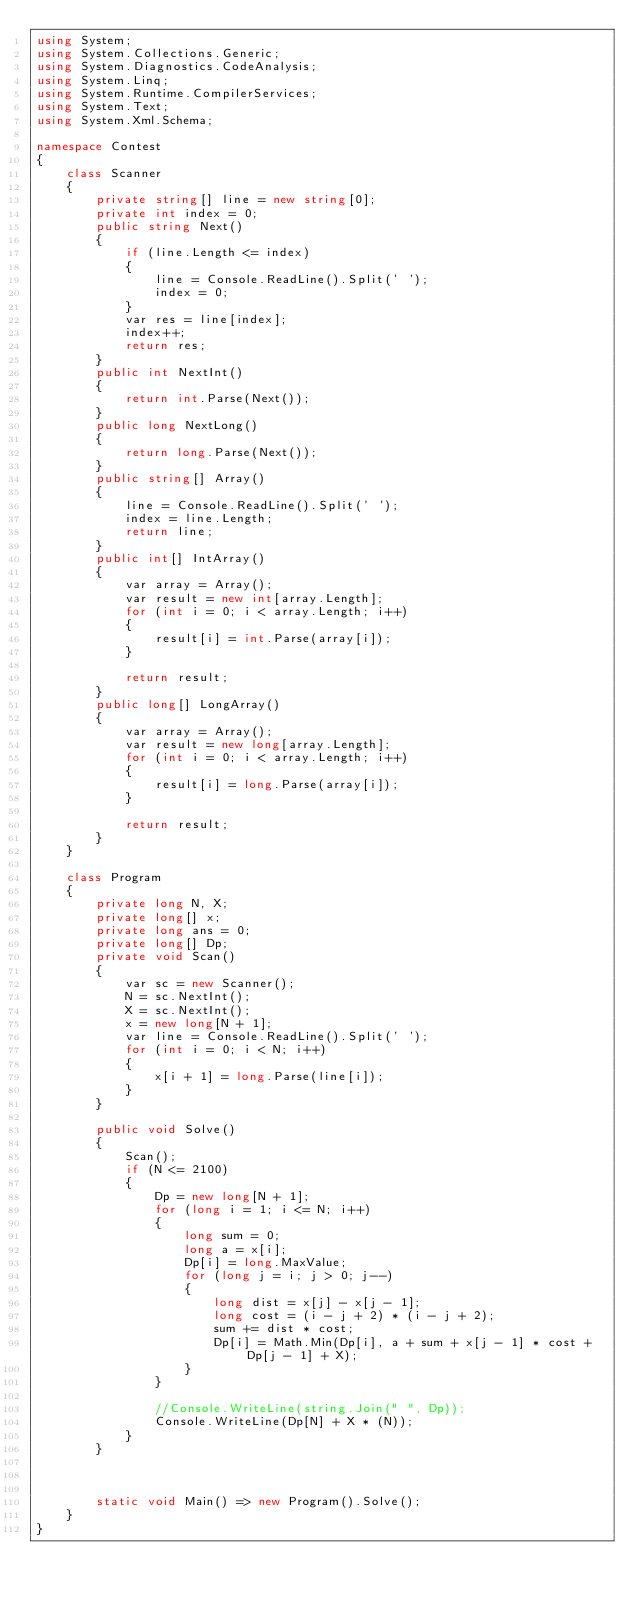Convert code to text. <code><loc_0><loc_0><loc_500><loc_500><_C#_>using System;
using System.Collections.Generic;
using System.Diagnostics.CodeAnalysis;
using System.Linq;
using System.Runtime.CompilerServices;
using System.Text;
using System.Xml.Schema;

namespace Contest
{
    class Scanner
    {
        private string[] line = new string[0];
        private int index = 0;
        public string Next()
        {
            if (line.Length <= index)
            {
                line = Console.ReadLine().Split(' ');
                index = 0;
            }
            var res = line[index];
            index++;
            return res;
        }
        public int NextInt()
        {
            return int.Parse(Next());
        }
        public long NextLong()
        {
            return long.Parse(Next());
        }
        public string[] Array()
        {
            line = Console.ReadLine().Split(' ');
            index = line.Length;
            return line;
        }
        public int[] IntArray()
        {
            var array = Array();
            var result = new int[array.Length];
            for (int i = 0; i < array.Length; i++)
            {
                result[i] = int.Parse(array[i]);
            }

            return result;
        }
        public long[] LongArray()
        {
            var array = Array();
            var result = new long[array.Length];
            for (int i = 0; i < array.Length; i++)
            {
                result[i] = long.Parse(array[i]);
            }

            return result;
        }
    }

    class Program
    {
        private long N, X;
        private long[] x;
        private long ans = 0;
        private long[] Dp;
        private void Scan()
        {
            var sc = new Scanner();
            N = sc.NextInt();
            X = sc.NextInt();
            x = new long[N + 1];
            var line = Console.ReadLine().Split(' ');
            for (int i = 0; i < N; i++)
            {
                x[i + 1] = long.Parse(line[i]);
            }
        }

        public void Solve()
        {
            Scan();
            if (N <= 2100)
            {
                Dp = new long[N + 1];
                for (long i = 1; i <= N; i++)
                {
                    long sum = 0;
                    long a = x[i];
                    Dp[i] = long.MaxValue;
                    for (long j = i; j > 0; j--)
                    {
                        long dist = x[j] - x[j - 1];
                        long cost = (i - j + 2) * (i - j + 2);
                        sum += dist * cost;
                        Dp[i] = Math.Min(Dp[i], a + sum + x[j - 1] * cost + Dp[j - 1] + X);
                    }
                }

                //Console.WriteLine(string.Join(" ", Dp));
                Console.WriteLine(Dp[N] + X * (N));
            }
        }



        static void Main() => new Program().Solve();
    }
}</code> 